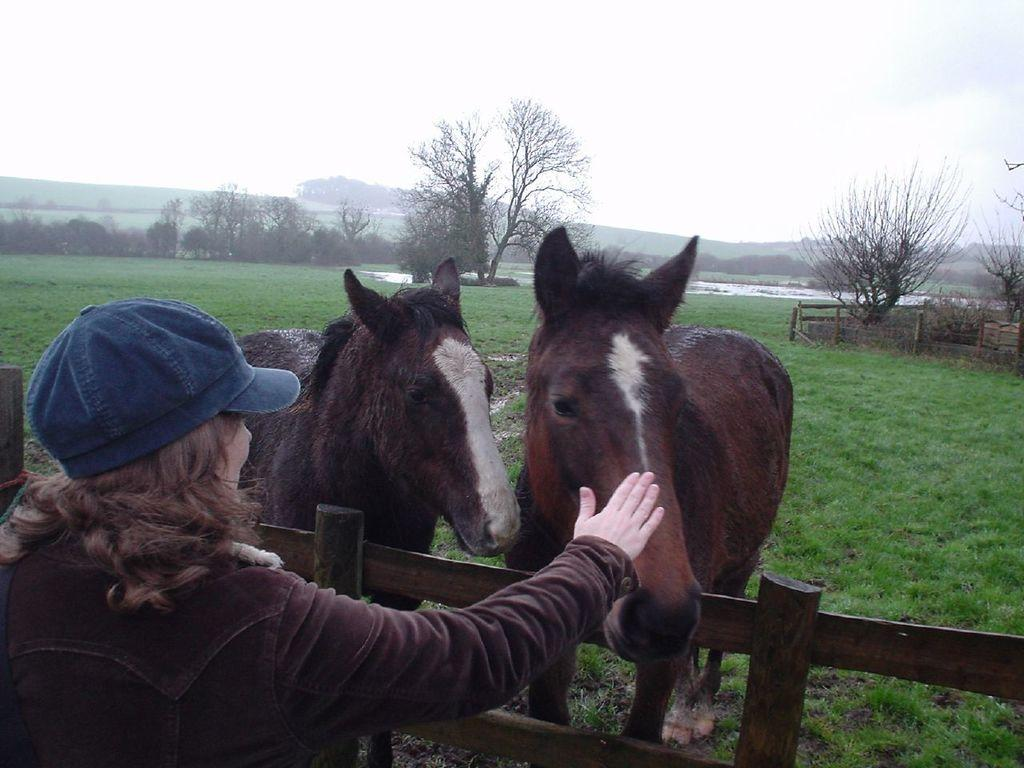What is the person in the image wearing on their head? The person in the image is wearing a cap. How many horses are present in the image? There are two horses in the image. What type of vegetation can be seen in the image? There are trees and plants in the image. What kind of barrier is visible in the image? There is wooden fencing in the image. What is the ground covered with in the image? The ground is covered with grass in the image. What can be seen in the background of the image? The sky is visible in the background of the image. What is the steel structure used for in the image? There is no steel structure present in the image. What is the tendency of the person with the cap in the image? The provided facts do not give any information about the person's tendencies, so we cannot answer this question. 